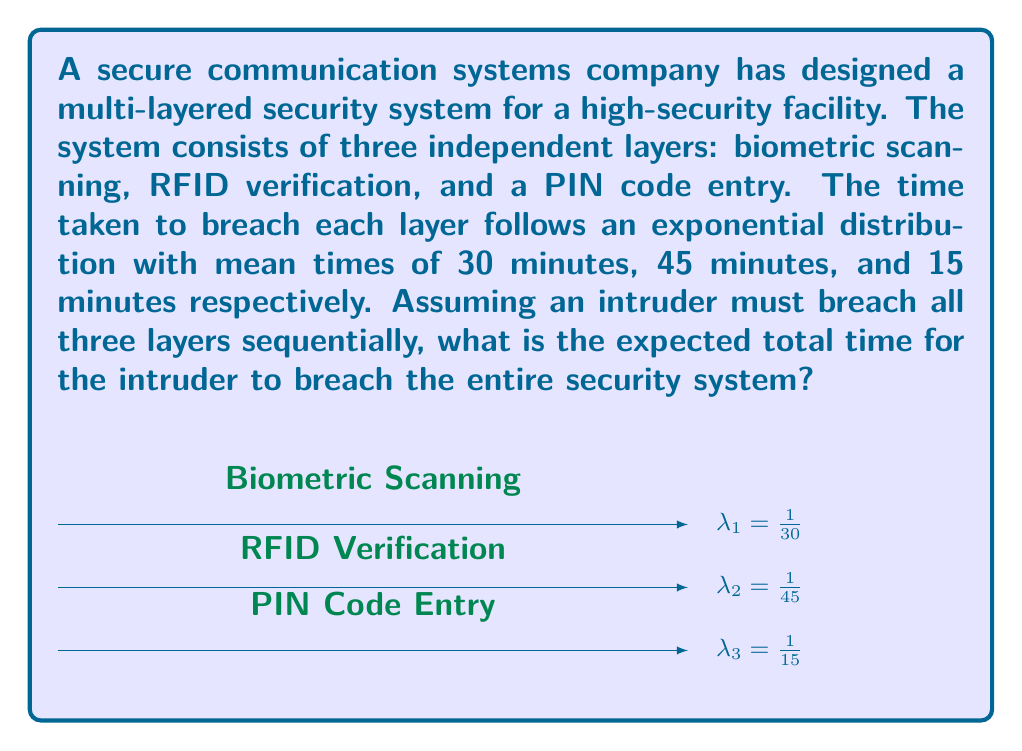Solve this math problem. To solve this problem, we need to understand the properties of exponential distributions and how they combine in a series of independent events.

1) For an exponential distribution, the expected value (mean) is the inverse of the rate parameter $\lambda$. So, we have:

   Layer 1 (Biometric): $\lambda_1 = \frac{1}{30}$
   Layer 2 (RFID): $\lambda_2 = \frac{1}{45}$
   Layer 3 (PIN): $\lambda_3 = \frac{1}{15}$

2) A key property of exponential distributions is that when independent exponential random variables are added, their means add linearly. This is because exponential distributions have the memoryless property.

3) Therefore, the expected total time to breach the system is the sum of the expected times for each layer:

   $$E[T_{total}] = E[T_1] + E[T_2] + E[T_3]$$

4) We know that for each layer, $E[T_i] = \frac{1}{\lambda_i}$, so:

   $$E[T_{total}] = \frac{1}{\lambda_1} + \frac{1}{\lambda_2} + \frac{1}{\lambda_3}$$

5) Substituting the values:

   $$E[T_{total}] = 30 + 45 + 15 = 90$$

Therefore, the expected total time for an intruder to breach all three layers of the security system is 90 minutes.
Answer: 90 minutes 